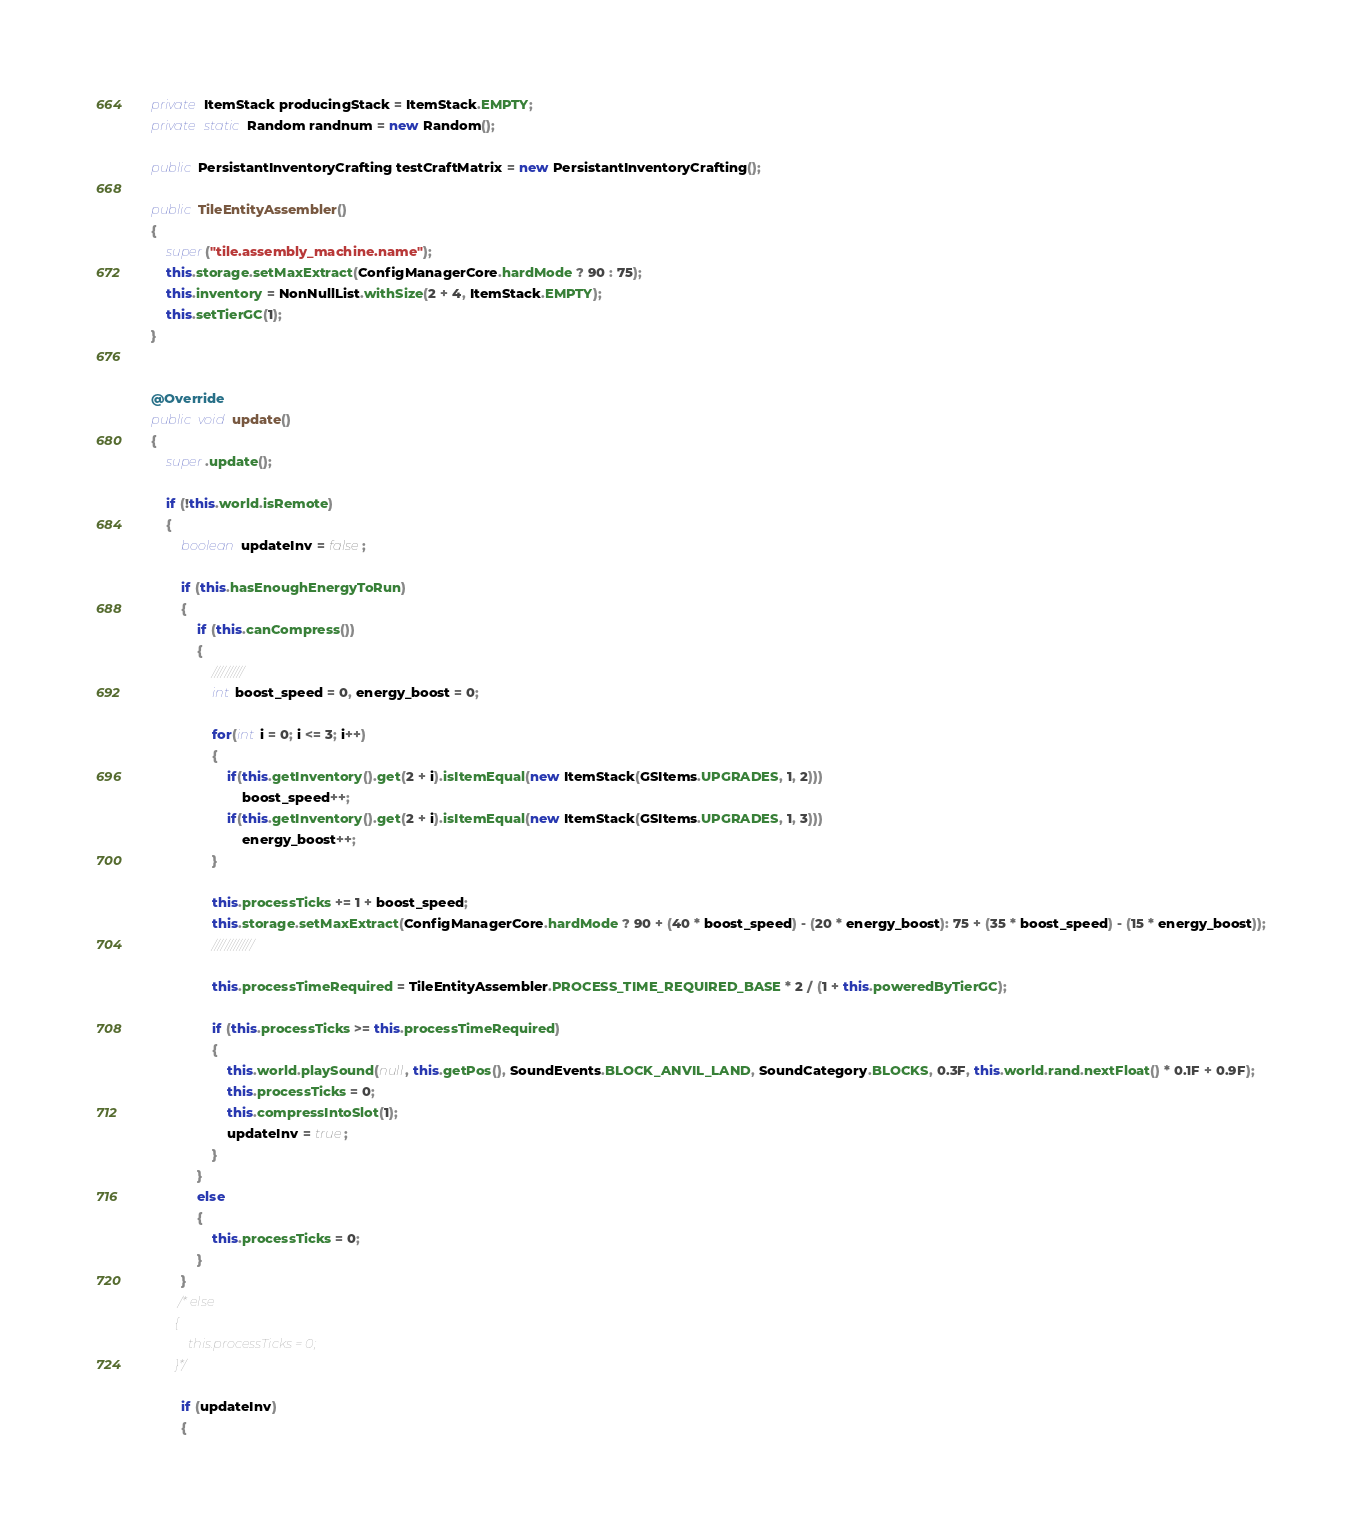Convert code to text. <code><loc_0><loc_0><loc_500><loc_500><_Java_>    private ItemStack producingStack = ItemStack.EMPTY;
    private static Random randnum = new Random();
  
    public PersistantInventoryCrafting testCraftMatrix = new PersistantInventoryCrafting();
    
    public TileEntityAssembler()
    {
    	super("tile.assembly_machine.name");
        this.storage.setMaxExtract(ConfigManagerCore.hardMode ? 90 : 75);
        this.inventory = NonNullList.withSize(2 + 4, ItemStack.EMPTY);
        this.setTierGC(1);
    }

       
    @Override
    public void update()
    {
        super.update();

        if (!this.world.isRemote)
        {
            boolean updateInv = false;

            if (this.hasEnoughEnergyToRun)
            {
                if (this.canCompress())
                {
                	//////////
                	int boost_speed = 0, energy_boost = 0;
                	
                	for(int i = 0; i <= 3; i++)
                	{
                		if(this.getInventory().get(2 + i).isItemEqual(new ItemStack(GSItems.UPGRADES, 1, 2)))
                			boost_speed++;
                		if(this.getInventory().get(2 + i).isItemEqual(new ItemStack(GSItems.UPGRADES, 1, 3)))
                			energy_boost++;
                	}
                	
                    this.processTicks += 1 + boost_speed;
                    this.storage.setMaxExtract(ConfigManagerCore.hardMode ? 90 + (40 * boost_speed) - (20 * energy_boost): 75 + (35 * boost_speed) - (15 * energy_boost));
                    /////////////
                    
                    this.processTimeRequired = TileEntityAssembler.PROCESS_TIME_REQUIRED_BASE * 2 / (1 + this.poweredByTierGC);

                    if (this.processTicks >= this.processTimeRequired)
                    {
                    	this.world.playSound(null, this.getPos(), SoundEvents.BLOCK_ANVIL_LAND, SoundCategory.BLOCKS, 0.3F, this.world.rand.nextFloat() * 0.1F + 0.9F);
                        this.processTicks = 0;
                        this.compressIntoSlot(1);
                        updateInv = true;
                    }
                }
                else
                {
                    this.processTicks = 0;
                }
            }
           /* else
            {
                this.processTicks = 0;
            }*/

            if (updateInv)
            {</code> 